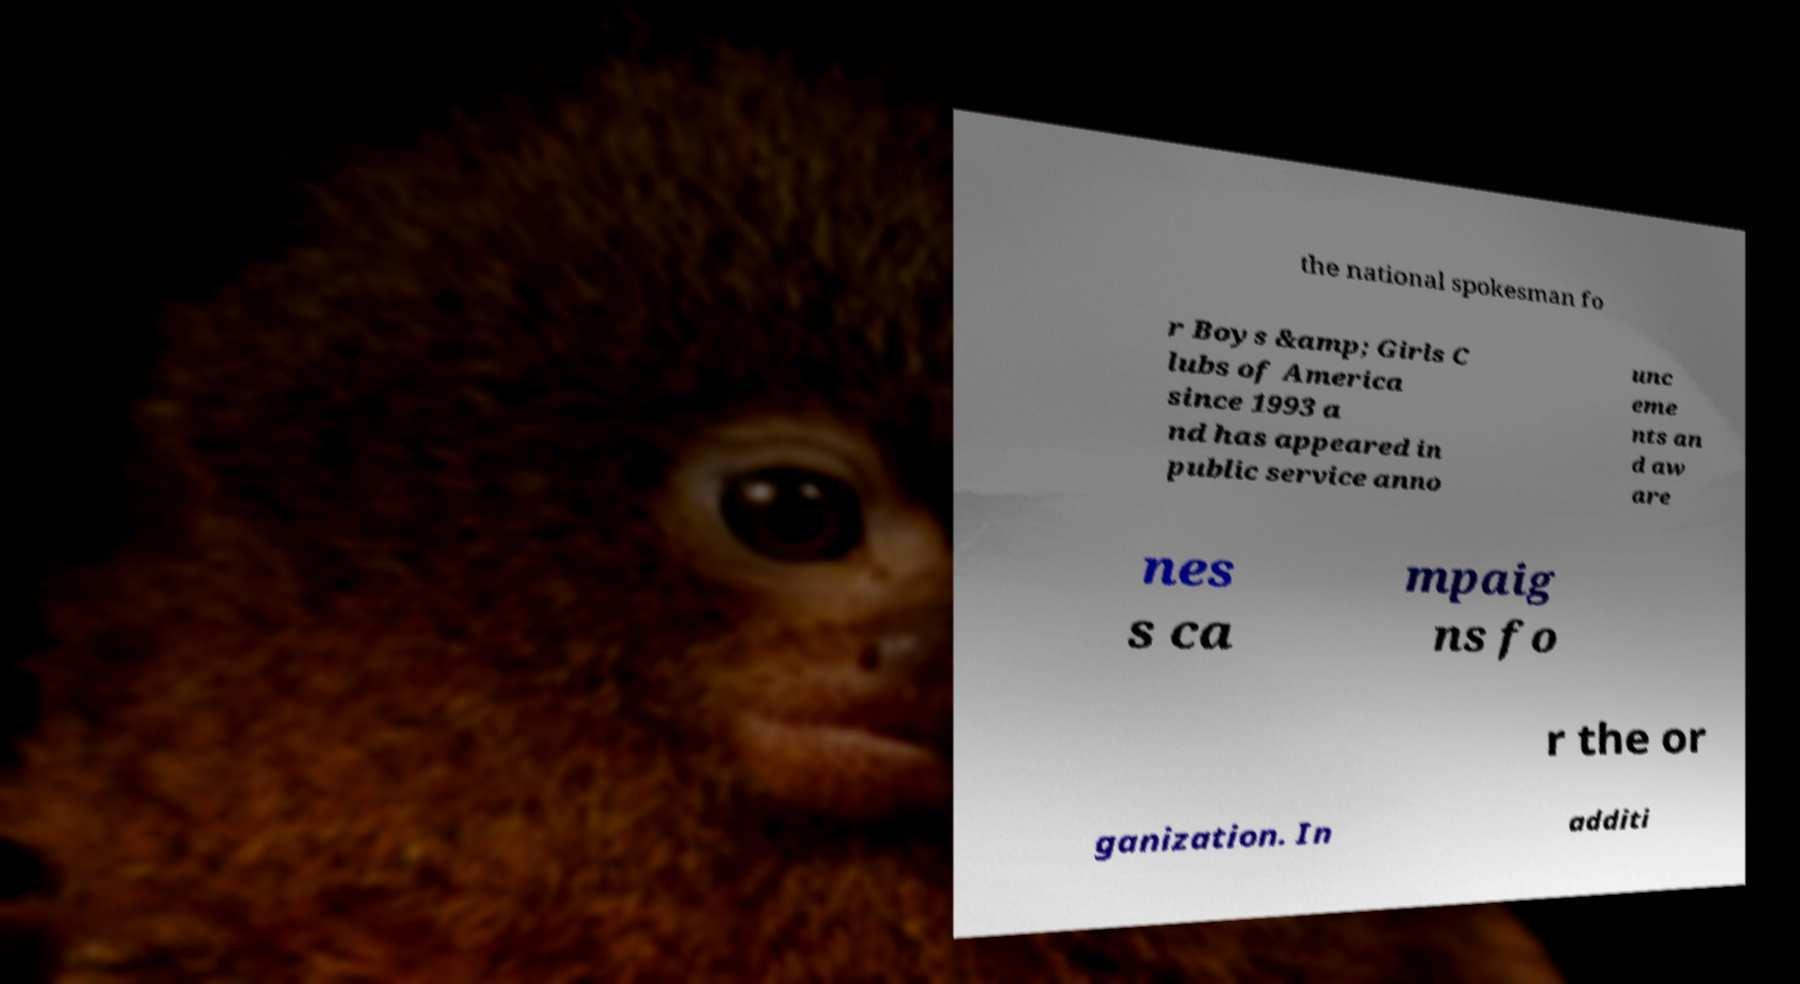Could you extract and type out the text from this image? the national spokesman fo r Boys &amp; Girls C lubs of America since 1993 a nd has appeared in public service anno unc eme nts an d aw are nes s ca mpaig ns fo r the or ganization. In additi 